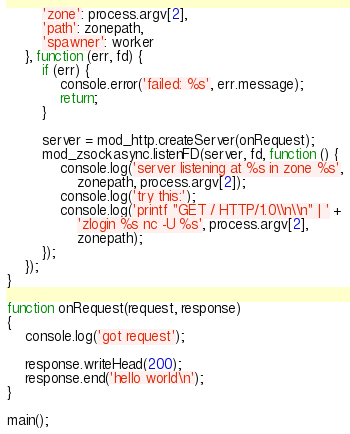<code> <loc_0><loc_0><loc_500><loc_500><_JavaScript_>	    'zone': process.argv[2],
	    'path': zonepath,
	    'spawner': worker
	}, function (err, fd) {
		if (err) {
			console.error('failed: %s', err.message);
			return;
		}

		server = mod_http.createServer(onRequest);
		mod_zsockasync.listenFD(server, fd, function () {
			console.log('server listening at %s in zone %s',
			    zonepath, process.argv[2]);
			console.log('try this:');
			console.log('printf "GET / HTTP/1.0\\n\\n" | ' +
			    'zlogin %s nc -U %s', process.argv[2],
			    zonepath);
		});
	});
}

function onRequest(request, response)
{
	console.log('got request');

	response.writeHead(200);
	response.end('hello world\n');
}

main();
</code> 